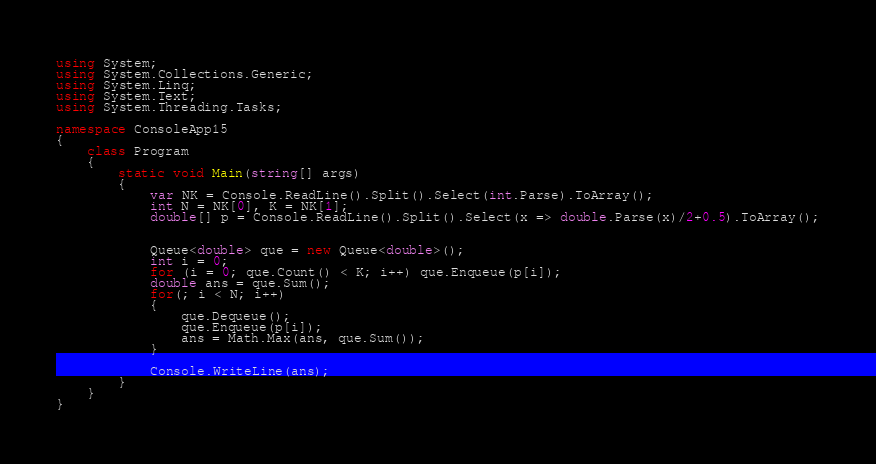<code> <loc_0><loc_0><loc_500><loc_500><_C#_>using System;
using System.Collections.Generic;
using System.Linq;
using System.Text;
using System.Threading.Tasks;

namespace ConsoleApp15
{
    class Program
    {
        static void Main(string[] args)
        {
            var NK = Console.ReadLine().Split().Select(int.Parse).ToArray();
            int N = NK[0], K = NK[1];
            double[] p = Console.ReadLine().Split().Select(x => double.Parse(x)/2+0.5).ToArray();

            
            Queue<double> que = new Queue<double>();
            int i = 0;
            for (i = 0; que.Count() < K; i++) que.Enqueue(p[i]);
            double ans = que.Sum();
            for(; i < N; i++)
            {
                que.Dequeue();
                que.Enqueue(p[i]);
                ans = Math.Max(ans, que.Sum());
            }

            Console.WriteLine(ans);
        }
    }
}
</code> 